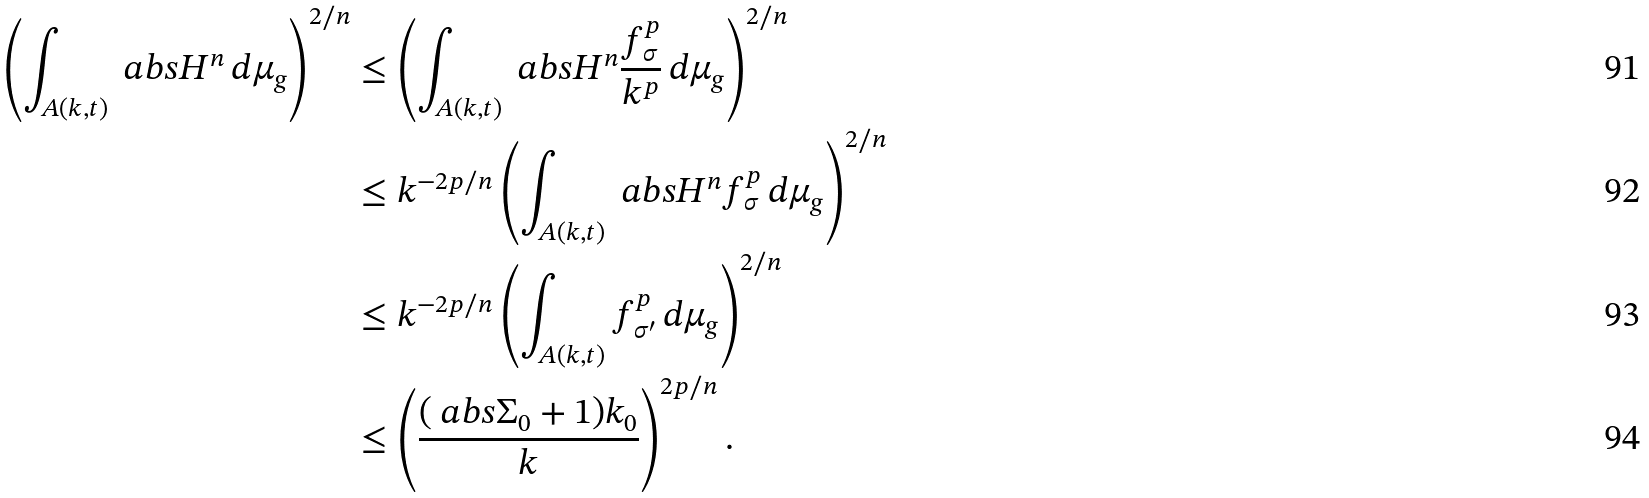Convert formula to latex. <formula><loc_0><loc_0><loc_500><loc_500>\left ( \int _ { A ( k , t ) } \ a b s { H } ^ { n } \, d \mu _ { g } \right ) ^ { 2 / n } & \leq \left ( \int _ { A ( k , t ) } \ a b s { H } ^ { n } \frac { f _ { \sigma } ^ { p } } { k ^ { p } } \, d \mu _ { g } \right ) ^ { 2 / n } \\ & \leq k ^ { - 2 p / n } \left ( \int _ { A ( k , t ) } \ a b s { H } ^ { n } f _ { \sigma } ^ { p } \, d \mu _ { g } \right ) ^ { 2 / n } \\ & \leq k ^ { - 2 p / n } \left ( \int _ { A ( k , t ) } f _ { \sigma ^ { \prime } } ^ { p } \, d \mu _ { g } \right ) ^ { 2 / n } \\ & \leq \left ( \frac { ( \ a b s { \Sigma _ { 0 } } + 1 ) k _ { 0 } } { k } \right ) ^ { 2 p / n } .</formula> 